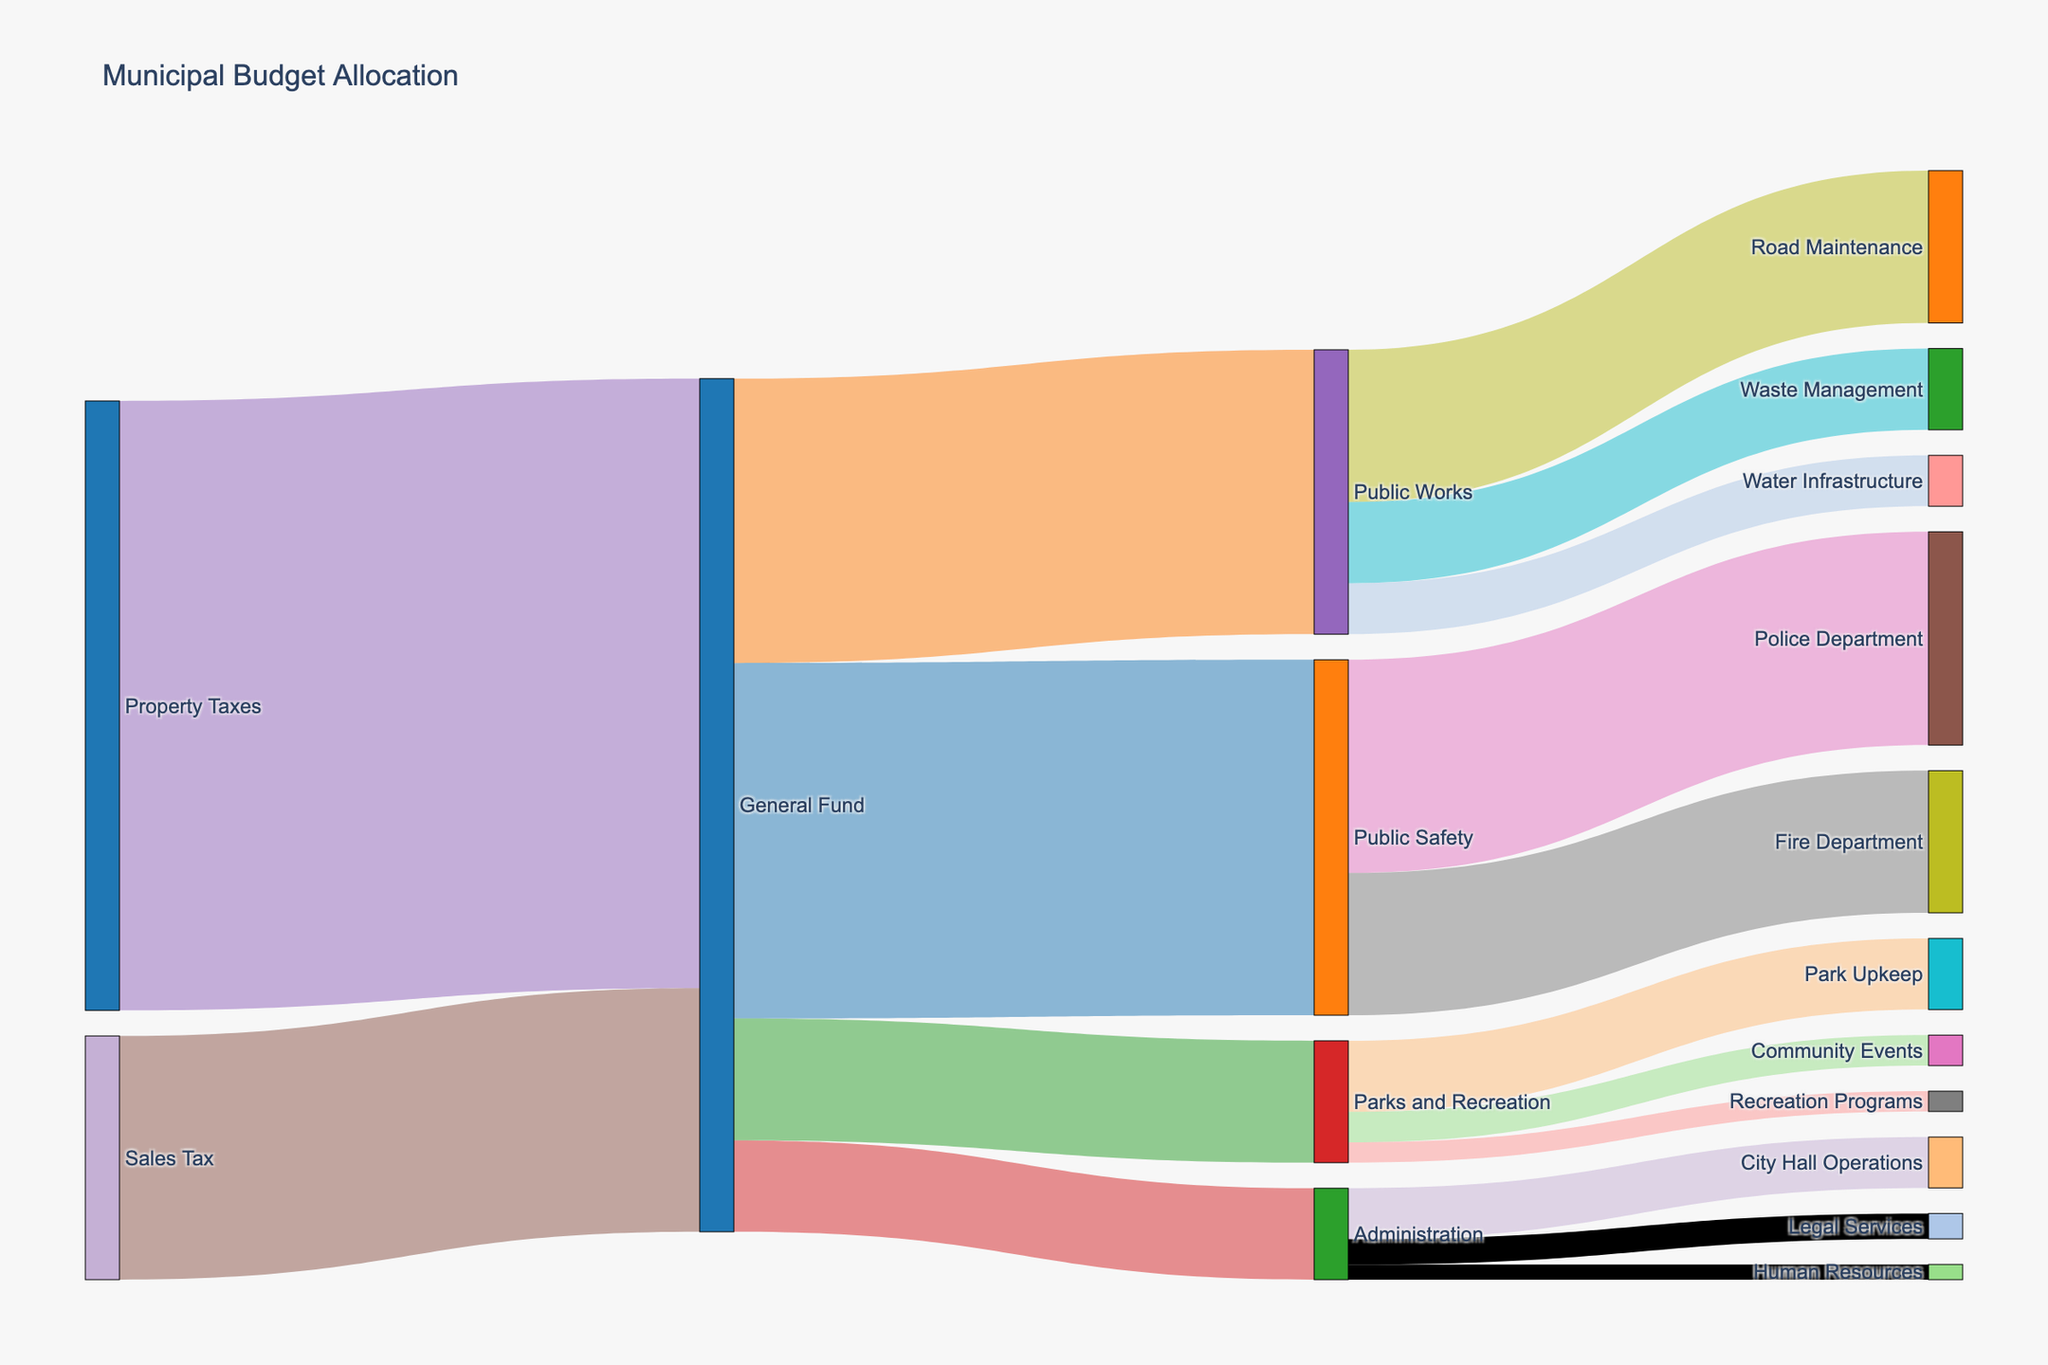what is the title of the figure? The title is usually placed at the top center of the figure. It summarizes the content being displayed. In this case, it's mentioned as "Municipal Budget Allocation" in the code.
Answer: Municipal Budget Allocation How much funding from Property Taxes goes to the General Fund? Examining the connections from Property Taxes, we see that 6,000,000 units are directed to the General Fund.
Answer: 6,000,000 What is the total allocation for Public Safety? First, identify all the connections leading to Public Safety. The General Fund allocates 3,500,000 units to Public Safety.
Answer: 3,500,000 Which sector receives the most funding from the General Fund? By comparing the values from the General Fund to various targets, Public Safety receives 3,500,000, Public Works 2,800,000, Parks and Recreation 1,200,000, and Administration 900,000. Public Safety receives the most funding.
Answer: Public Safety Which department under Public Safety receives more funding, Police or Fire Department? By examining the connections under Public Safety: the Police Department receives 2,100,000 while the Fire Department receives 1,400,000. The Police Department receives more.
Answer: Police Department What is the combined funding for Road Maintenance and Waste Management under Public Works? Road Maintenance receives 1,500,000, and Waste Management receives 800,000. Summing these values gives 1,500,000 + 800,000 = 2,300,000.
Answer: 2,300,000 How is the funding allocated within the General Fund? Summing up the values from the General Fund: Public Safety 3,500,000, Public Works 2,800,000, Parks and Recreation 1,200,000, and Administration 900,000. Total is 3,500,000 + 2,800,000 + 1,200,000 + 900,000 = 8,400,000. This matches the sum of incoming funds: Property Taxes (6,000,000) and Sales Tax (2,400,000) totaling 8,400,000. Each allocation is given directly by the values.
Answer: 3,500,000 to Public Safety, 2,800,000 to Public Works, 1,200,000 to Parks and Recreation, 900,000 to Administration What fraction of Public Works' budget is dedicated to Water Infrastructure? Public Works has a total budget of 2,800,000. Water Infrastructure receives 500,000. The fraction is 500,000 / 2,800,000 = 5/28 or approximately 17.86%.
Answer: 17.86% What is the difference in funding between City Hall Operations and Legal Services under Administration? City Hall Operations receive 500,000 and Legal Services receive 250,000. The difference is 500,000 - 250,000 = 250,000.
Answer: 250,000 Which receives more funding, Community Events or Recreation Programs under Parks and Recreation? And by how much? Community Events receive 300,000, and Recreation Programs receive 200,000. Community Events receive 100,000 more than Recreation Programs.
Answer: Community Events by 100,000 